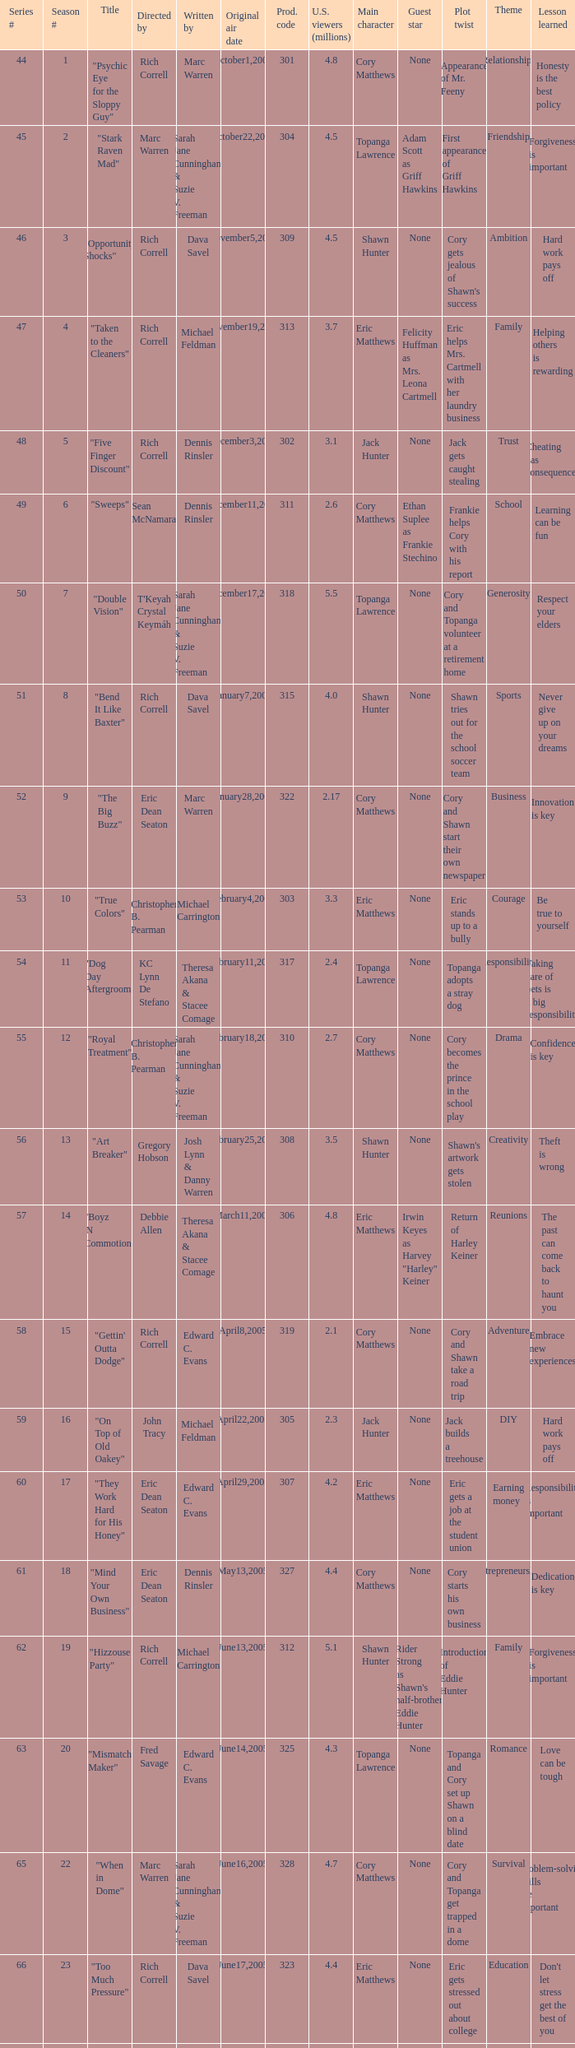What is the title of the episode directed by Rich Correll and written by Dennis Rinsler? "Five Finger Discount". 